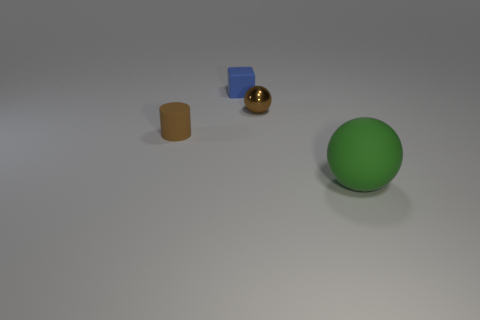What materials do the other objects appear to be made of? The cylindrical object appears to have a plastic-like material with a rough texture, the cube seems to be made of a reflective metal, and the small sphere has a smooth, polished metallic surface. 